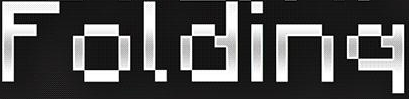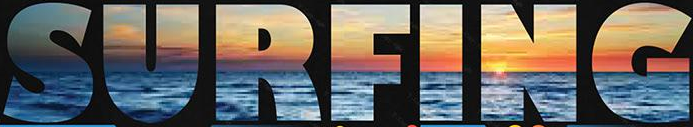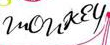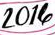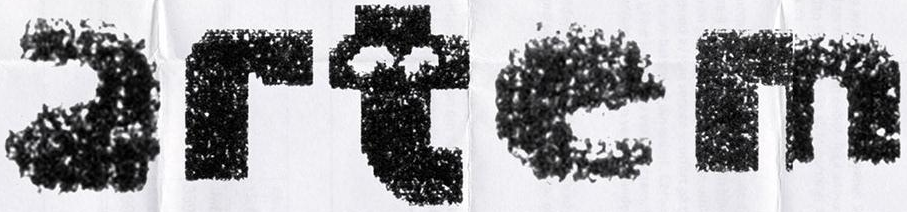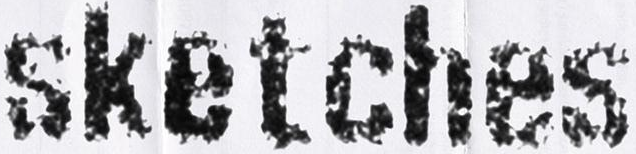Identify the words shown in these images in order, separated by a semicolon. Folding; SURFING; monkey; 2014; artem; sketches 